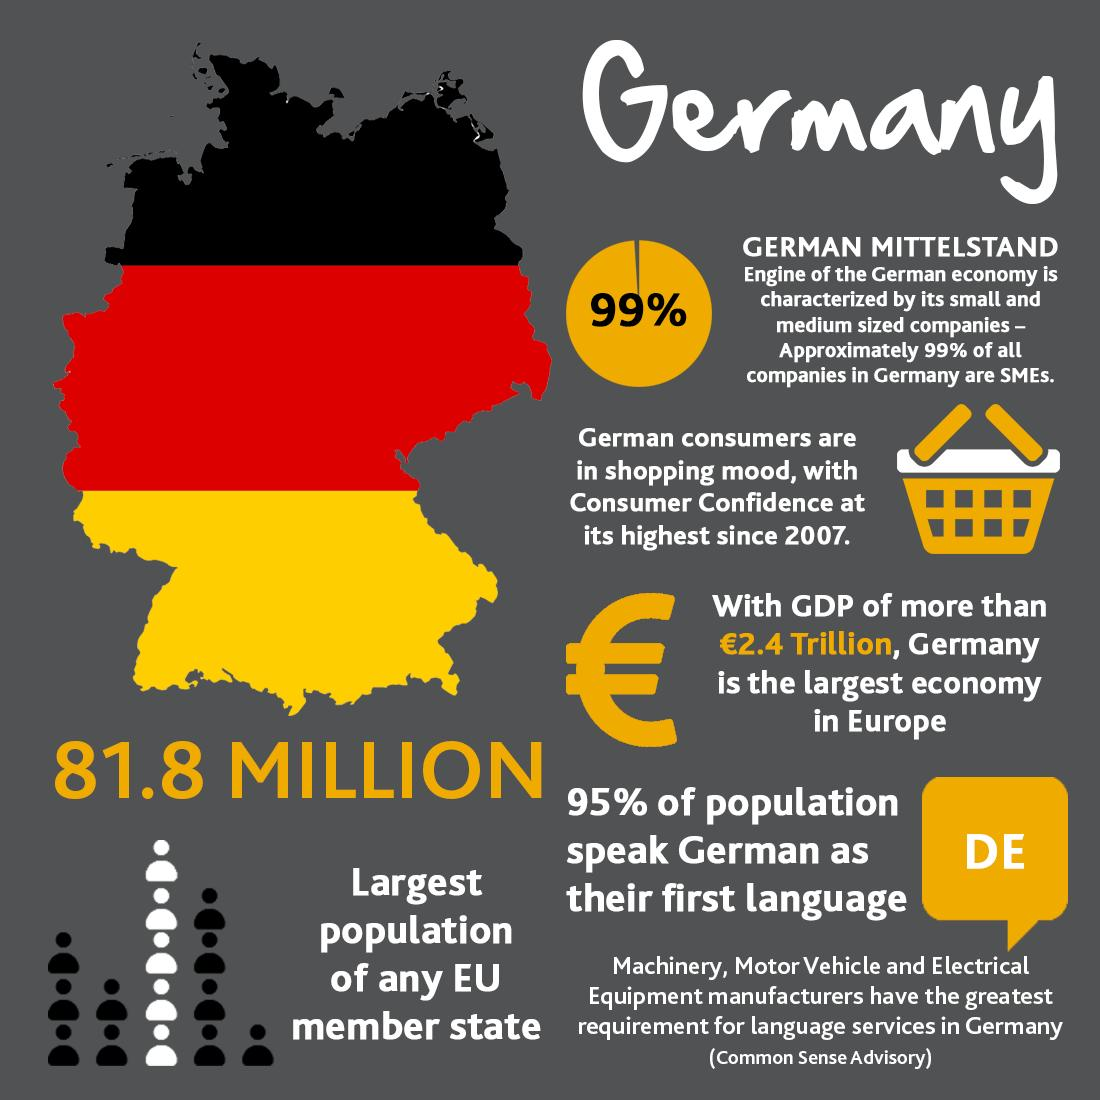Draw attention to some important aspects in this diagram. The flag of Germany consists of three colors. 